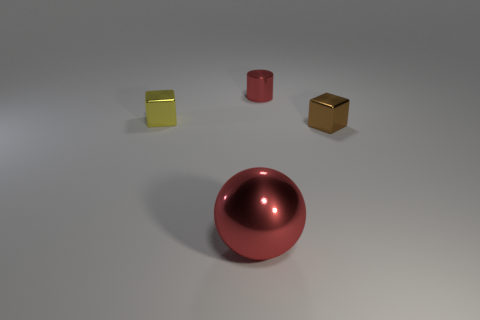Add 3 metallic cubes. How many objects exist? 7 Subtract all cylinders. How many objects are left? 3 Subtract all big red shiny balls. Subtract all small green metallic cubes. How many objects are left? 3 Add 4 tiny metallic cylinders. How many tiny metallic cylinders are left? 5 Add 4 large matte cylinders. How many large matte cylinders exist? 4 Subtract 0 blue balls. How many objects are left? 4 